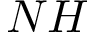Convert formula to latex. <formula><loc_0><loc_0><loc_500><loc_500>N H</formula> 